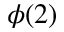Convert formula to latex. <formula><loc_0><loc_0><loc_500><loc_500>\phi ( 2 )</formula> 